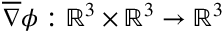<formula> <loc_0><loc_0><loc_500><loc_500>\overline { \nabla } \phi \colon \mathbb { R } ^ { 3 } \times \mathbb { R } ^ { 3 } \to \mathbb { R } ^ { 3 }</formula> 